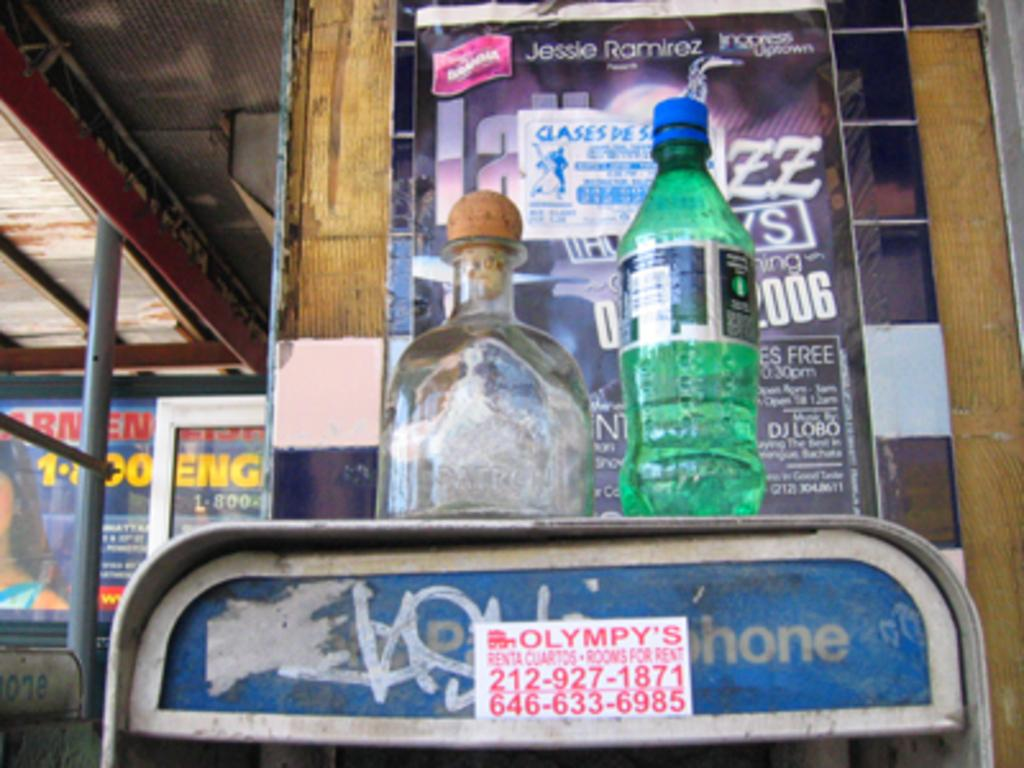Provide a one-sentence caption for the provided image. A pay phone that has a sprite bottle and another bottle on top. 